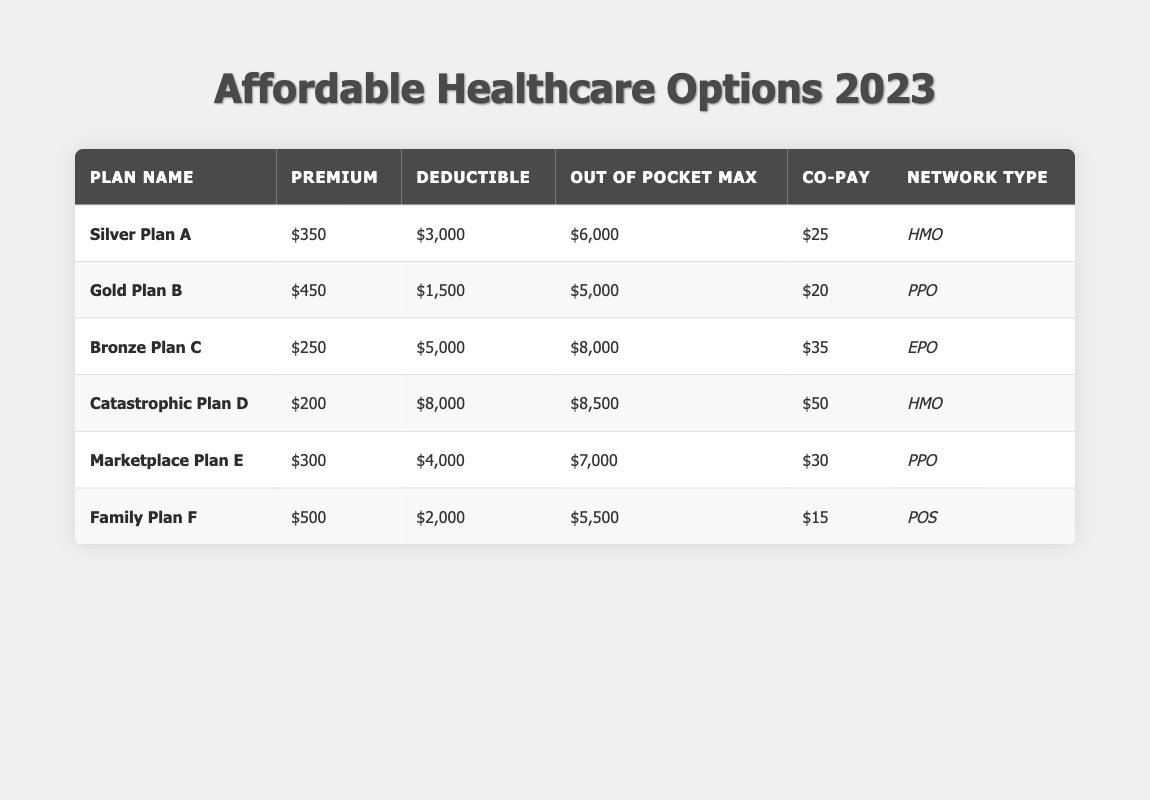What is the premium for the Gold Plan B? The table indicates that the premium for Gold Plan B is listed directly under the "Premium" column, which shows a value of 450.
Answer: 450 What is the deductible for the Silver Plan A? The deductible for Silver Plan A can be found in the table's "Deductible" column, where it states the value is 3000.
Answer: 3000 Which plan has the highest out-of-pocket maximum? By comparing the "Out of Pocket Max" values for all plans in the table, it can be determined that the Bronze Plan C has the highest value at 8000.
Answer: Bronze Plan C What is the average premium of all plans? To find the average premium, sum the premiums of all plans: (350 + 450 + 250 + 200 + 300 + 500) = 2050. There are 6 plans, so the average is 2050 / 6 ≈ 341.67.
Answer: 341.67 Which plan has the lowest co-pay? The co-pay values for all plans are compared, and the plan with the lowest co-pay is the Family Plan F, which has a co-pay of 15.
Answer: Family Plan F Does the Catastrophic Plan D have a lower deductible than the Marketplace Plan E? The deductible for Catastrophic Plan D is 8000 while for Marketplace Plan E it is 4000. Since 8000 is greater than 4000, the answer is no.
Answer: No What is the difference in premium between the Family Plan F and the Catastrophic Plan D? The premium for Family Plan F is 500 and for Catastrophic Plan D is 200. The difference is calculated as 500 - 200 = 300.
Answer: 300 Is the deductible for the Gold Plan B less than the average deductible of all plans? The average deductible can be computed by summing the deductibles of all plans: (3000 + 1500 + 5000 + 8000 + 4000 + 2000) = 24000. The average is 24000 / 6 = 4000. The deductible for Gold Plan B is 1500, which is less than 4000, so the answer is yes.
Answer: Yes Which plans have a network type of PPO? The plans with a PPO network type are Gold Plan B and Marketplace Plan E, as can be seen in the "Network Type" column.
Answer: Gold Plan B, Marketplace Plan E What is the total out-of-pocket maximum for all plans? The total out-of-pocket maximum is the sum of all the values in the "Out of Pocket Max" column: (6000 + 5000 + 8000 + 8500 + 7000 + 5500) = 41500.
Answer: 41500 